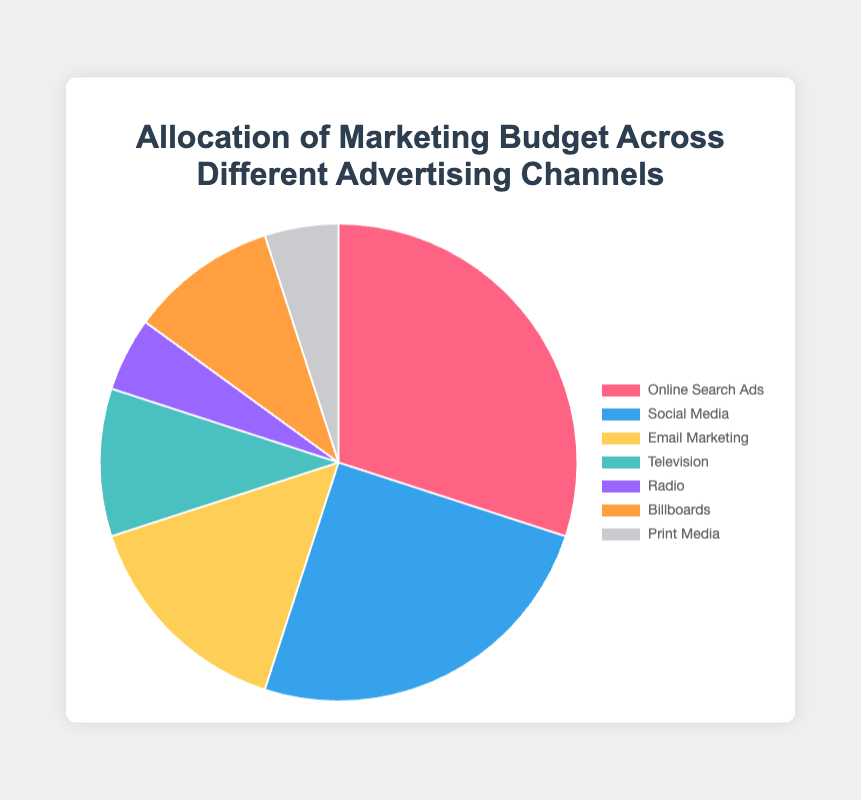Which advertising channel has the highest percentage of the marketing budget? The advertising channel with the highest percentage can be identified by looking for the largest section in the pie chart. The segment for "Online Search Ads" is the largest at 30%.
Answer: Online Search Ads Which two advertising channels collectively account for half of the marketing budget? To find the combination that accounts for 50% of the marketing budget, look for the two largest segments. "Online Search Ads" is 30% and "Social Media" is 25%, together they make 55%. By quickly assessing the visual segments, it's clear these two combined surpass half.
Answer: Online Search Ads and Social Media What is the combined percentage allocated to traditional advertising channels (Television, Radio, and Print Media)? Locate the sections for Television (10%), Radio (5%), and Print Media (5%) on the chart. Add these percentages together: 10% + 5% + 5% = 20%.
Answer: 20% Which advertising channels have the same percentage of the budget allocated? Identify the segments with the same size. Both "Radio" and "Print Media" have the same budget allocation, each contributing 5%. Additionally, "Television" and "Billboards" are equal at 10% each.
Answer: Radio and Print Media, Television and Billboards What is the average percentage allocated to all advertising channels? Sum all the percentages: 30% (Online Search Ads) + 25% (Social Media) + 15% (Email Marketing) + 10% (Television) + 5% (Radio) + 10% (Billboards) + 5% (Print Media) = 100%. Since there are 7 channels, divide the total by 7: 100% / 7 ≈ 14.29%.
Answer: 14.29% By how much does the percentage allocated to the largest channel exceed the smallest channel? The largest segment is "Online Search Ads" at 30%, and the smallest segments are "Radio" and "Print Media" at 5% each. The difference is calculated as 30% - 5% = 25%.
Answer: 25% What color represents Social Media in the pie chart? Find the color associated with "Social Media" in the chart legend. The color for "Social Media" is indicated by a blue section.
Answer: Blue 